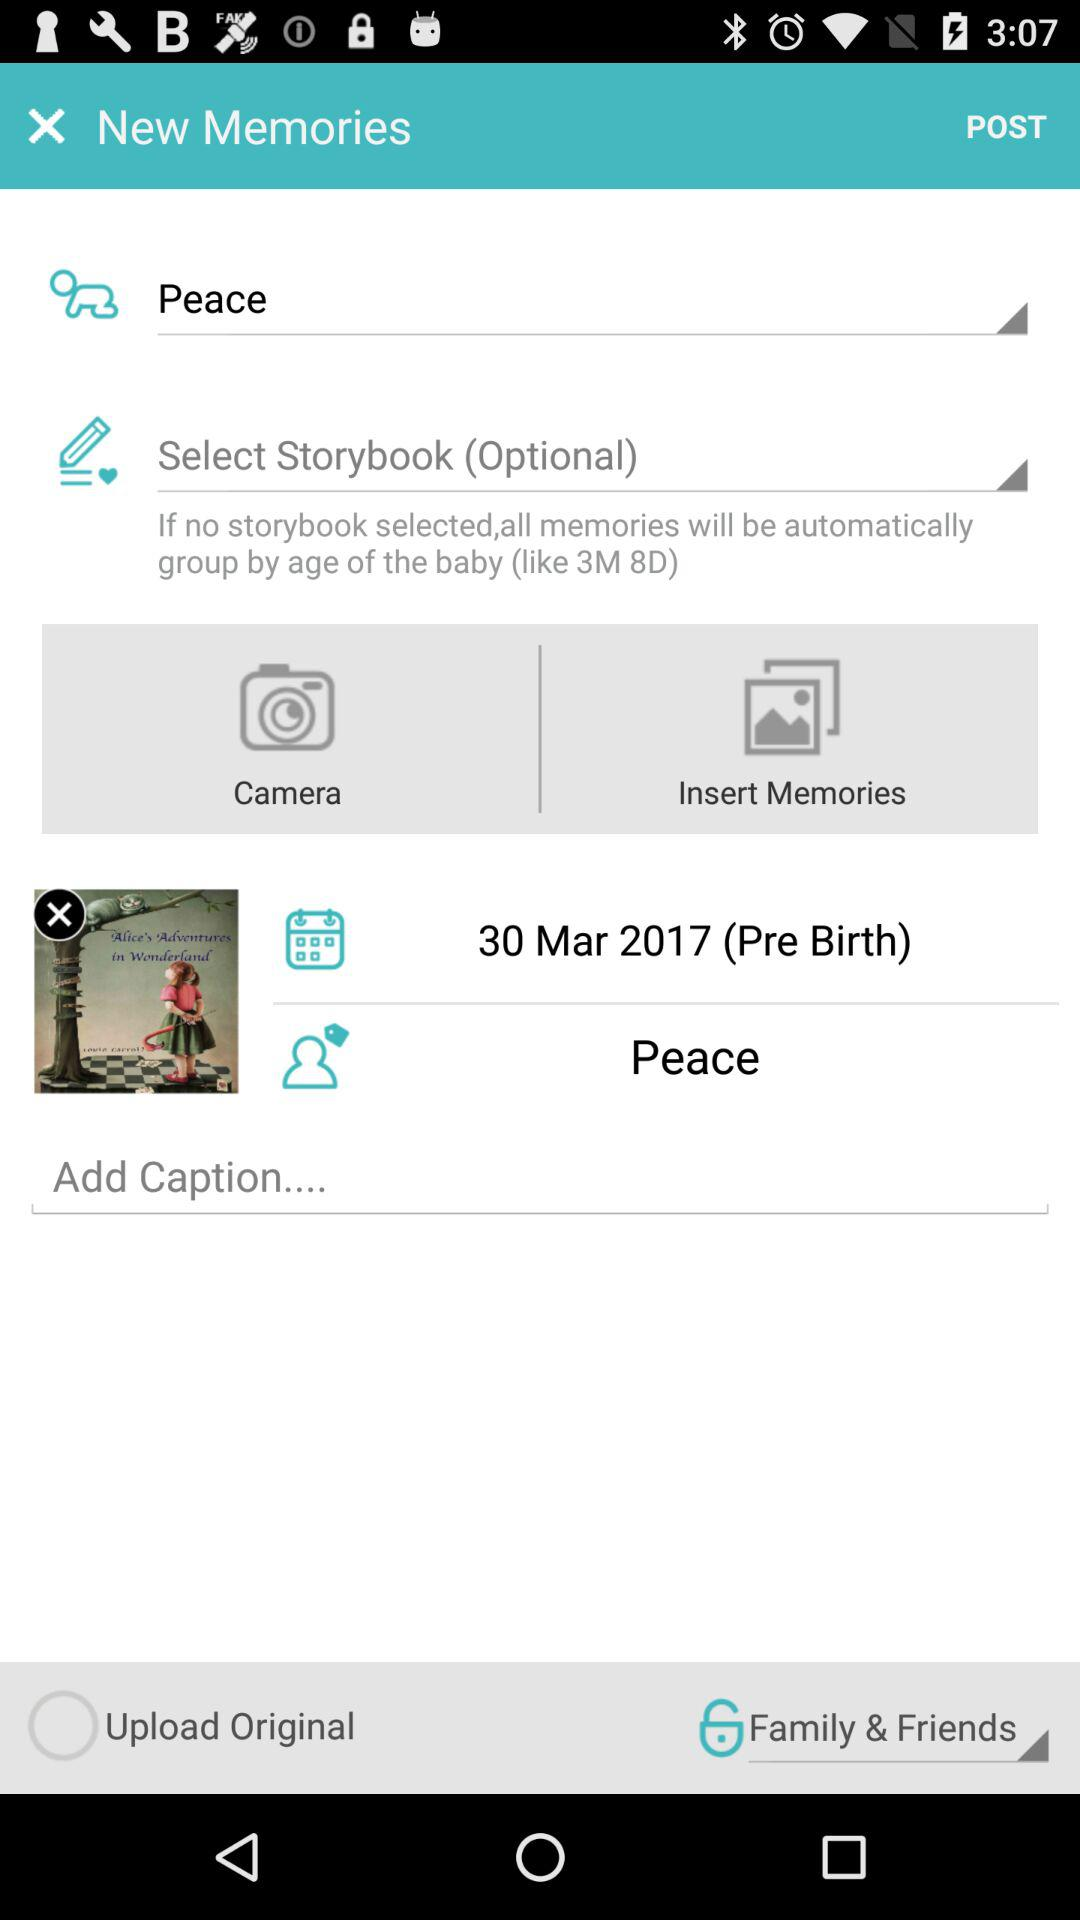Who can see the post? The post can be seen by family and friends. 